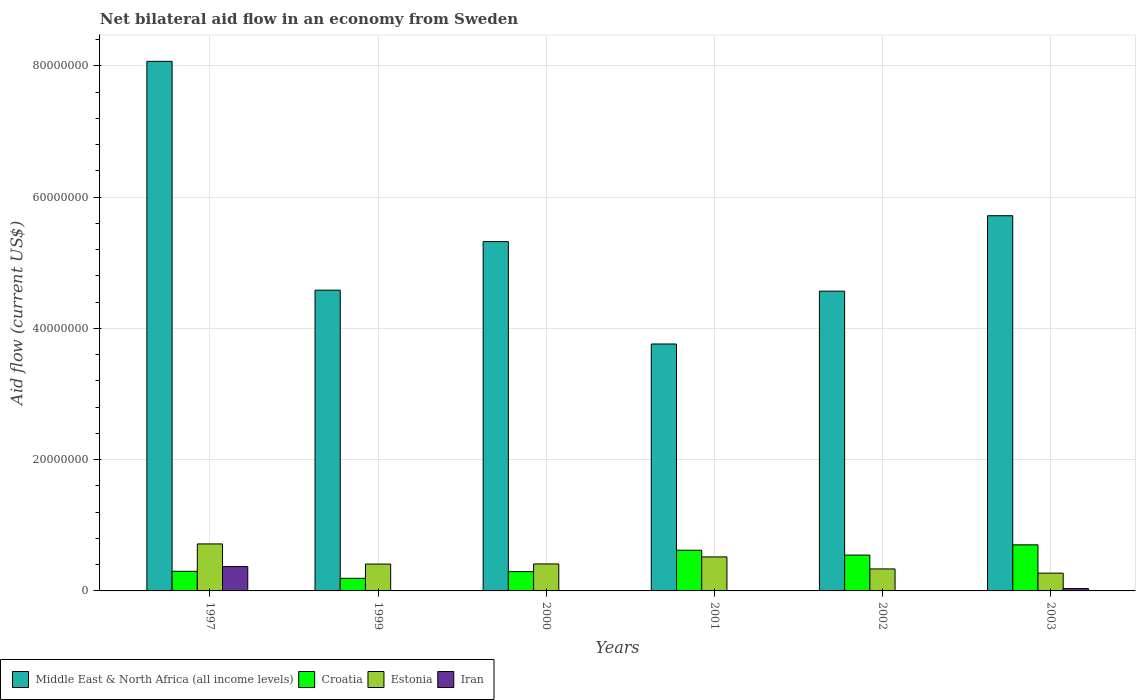How many different coloured bars are there?
Ensure brevity in your answer.  4. How many groups of bars are there?
Make the answer very short. 6. Are the number of bars per tick equal to the number of legend labels?
Keep it short and to the point. Yes. Are the number of bars on each tick of the X-axis equal?
Offer a terse response. Yes. How many bars are there on the 6th tick from the left?
Your answer should be very brief. 4. How many bars are there on the 1st tick from the right?
Ensure brevity in your answer.  4. In how many cases, is the number of bars for a given year not equal to the number of legend labels?
Make the answer very short. 0. What is the net bilateral aid flow in Estonia in 1997?
Your answer should be compact. 7.16e+06. Across all years, what is the maximum net bilateral aid flow in Croatia?
Ensure brevity in your answer.  7.02e+06. In which year was the net bilateral aid flow in Estonia maximum?
Your answer should be compact. 1997. What is the total net bilateral aid flow in Iran in the graph?
Give a very brief answer. 4.20e+06. What is the difference between the net bilateral aid flow in Middle East & North Africa (all income levels) in 1999 and that in 2003?
Ensure brevity in your answer.  -1.13e+07. What is the difference between the net bilateral aid flow in Middle East & North Africa (all income levels) in 2003 and the net bilateral aid flow in Estonia in 2002?
Offer a very short reply. 5.38e+07. What is the average net bilateral aid flow in Croatia per year?
Offer a very short reply. 4.42e+06. In the year 2001, what is the difference between the net bilateral aid flow in Croatia and net bilateral aid flow in Estonia?
Your answer should be compact. 1.02e+06. What is the ratio of the net bilateral aid flow in Iran in 1997 to that in 2003?
Your answer should be compact. 10.31. What is the difference between the highest and the second highest net bilateral aid flow in Croatia?
Make the answer very short. 8.20e+05. What is the difference between the highest and the lowest net bilateral aid flow in Croatia?
Offer a terse response. 5.10e+06. What does the 3rd bar from the left in 2001 represents?
Give a very brief answer. Estonia. What does the 3rd bar from the right in 2001 represents?
Your response must be concise. Croatia. Is it the case that in every year, the sum of the net bilateral aid flow in Croatia and net bilateral aid flow in Iran is greater than the net bilateral aid flow in Estonia?
Ensure brevity in your answer.  No. How many bars are there?
Your answer should be compact. 24. Are all the bars in the graph horizontal?
Ensure brevity in your answer.  No. Does the graph contain any zero values?
Your response must be concise. No. Where does the legend appear in the graph?
Offer a terse response. Bottom left. What is the title of the graph?
Offer a very short reply. Net bilateral aid flow in an economy from Sweden. What is the Aid flow (current US$) in Middle East & North Africa (all income levels) in 1997?
Provide a succinct answer. 8.07e+07. What is the Aid flow (current US$) in Croatia in 1997?
Your response must be concise. 2.99e+06. What is the Aid flow (current US$) of Estonia in 1997?
Provide a short and direct response. 7.16e+06. What is the Aid flow (current US$) of Iran in 1997?
Provide a succinct answer. 3.71e+06. What is the Aid flow (current US$) of Middle East & North Africa (all income levels) in 1999?
Offer a very short reply. 4.58e+07. What is the Aid flow (current US$) of Croatia in 1999?
Provide a succinct answer. 1.92e+06. What is the Aid flow (current US$) in Estonia in 1999?
Offer a very short reply. 4.09e+06. What is the Aid flow (current US$) of Middle East & North Africa (all income levels) in 2000?
Offer a terse response. 5.32e+07. What is the Aid flow (current US$) of Croatia in 2000?
Your response must be concise. 2.94e+06. What is the Aid flow (current US$) in Estonia in 2000?
Offer a very short reply. 4.11e+06. What is the Aid flow (current US$) in Iran in 2000?
Give a very brief answer. 6.00e+04. What is the Aid flow (current US$) in Middle East & North Africa (all income levels) in 2001?
Ensure brevity in your answer.  3.76e+07. What is the Aid flow (current US$) in Croatia in 2001?
Your answer should be very brief. 6.20e+06. What is the Aid flow (current US$) in Estonia in 2001?
Ensure brevity in your answer.  5.18e+06. What is the Aid flow (current US$) of Middle East & North Africa (all income levels) in 2002?
Make the answer very short. 4.57e+07. What is the Aid flow (current US$) of Croatia in 2002?
Offer a terse response. 5.46e+06. What is the Aid flow (current US$) in Estonia in 2002?
Offer a very short reply. 3.35e+06. What is the Aid flow (current US$) in Middle East & North Africa (all income levels) in 2003?
Provide a succinct answer. 5.72e+07. What is the Aid flow (current US$) of Croatia in 2003?
Make the answer very short. 7.02e+06. What is the Aid flow (current US$) of Estonia in 2003?
Your answer should be very brief. 2.71e+06. What is the Aid flow (current US$) in Iran in 2003?
Provide a succinct answer. 3.60e+05. Across all years, what is the maximum Aid flow (current US$) in Middle East & North Africa (all income levels)?
Make the answer very short. 8.07e+07. Across all years, what is the maximum Aid flow (current US$) in Croatia?
Provide a succinct answer. 7.02e+06. Across all years, what is the maximum Aid flow (current US$) of Estonia?
Your answer should be very brief. 7.16e+06. Across all years, what is the maximum Aid flow (current US$) in Iran?
Provide a short and direct response. 3.71e+06. Across all years, what is the minimum Aid flow (current US$) of Middle East & North Africa (all income levels)?
Ensure brevity in your answer.  3.76e+07. Across all years, what is the minimum Aid flow (current US$) of Croatia?
Keep it short and to the point. 1.92e+06. Across all years, what is the minimum Aid flow (current US$) in Estonia?
Provide a short and direct response. 2.71e+06. Across all years, what is the minimum Aid flow (current US$) of Iran?
Give a very brief answer. 10000. What is the total Aid flow (current US$) in Middle East & North Africa (all income levels) in the graph?
Provide a short and direct response. 3.20e+08. What is the total Aid flow (current US$) of Croatia in the graph?
Ensure brevity in your answer.  2.65e+07. What is the total Aid flow (current US$) of Estonia in the graph?
Offer a very short reply. 2.66e+07. What is the total Aid flow (current US$) of Iran in the graph?
Your answer should be very brief. 4.20e+06. What is the difference between the Aid flow (current US$) of Middle East & North Africa (all income levels) in 1997 and that in 1999?
Provide a short and direct response. 3.49e+07. What is the difference between the Aid flow (current US$) of Croatia in 1997 and that in 1999?
Your answer should be compact. 1.07e+06. What is the difference between the Aid flow (current US$) in Estonia in 1997 and that in 1999?
Your response must be concise. 3.07e+06. What is the difference between the Aid flow (current US$) in Iran in 1997 and that in 1999?
Your answer should be very brief. 3.68e+06. What is the difference between the Aid flow (current US$) in Middle East & North Africa (all income levels) in 1997 and that in 2000?
Make the answer very short. 2.75e+07. What is the difference between the Aid flow (current US$) of Croatia in 1997 and that in 2000?
Provide a succinct answer. 5.00e+04. What is the difference between the Aid flow (current US$) in Estonia in 1997 and that in 2000?
Your answer should be compact. 3.05e+06. What is the difference between the Aid flow (current US$) in Iran in 1997 and that in 2000?
Make the answer very short. 3.65e+06. What is the difference between the Aid flow (current US$) of Middle East & North Africa (all income levels) in 1997 and that in 2001?
Provide a succinct answer. 4.31e+07. What is the difference between the Aid flow (current US$) of Croatia in 1997 and that in 2001?
Your answer should be compact. -3.21e+06. What is the difference between the Aid flow (current US$) in Estonia in 1997 and that in 2001?
Offer a very short reply. 1.98e+06. What is the difference between the Aid flow (current US$) of Iran in 1997 and that in 2001?
Offer a very short reply. 3.68e+06. What is the difference between the Aid flow (current US$) of Middle East & North Africa (all income levels) in 1997 and that in 2002?
Keep it short and to the point. 3.50e+07. What is the difference between the Aid flow (current US$) in Croatia in 1997 and that in 2002?
Your answer should be very brief. -2.47e+06. What is the difference between the Aid flow (current US$) in Estonia in 1997 and that in 2002?
Offer a very short reply. 3.81e+06. What is the difference between the Aid flow (current US$) in Iran in 1997 and that in 2002?
Your answer should be very brief. 3.70e+06. What is the difference between the Aid flow (current US$) of Middle East & North Africa (all income levels) in 1997 and that in 2003?
Offer a very short reply. 2.35e+07. What is the difference between the Aid flow (current US$) of Croatia in 1997 and that in 2003?
Keep it short and to the point. -4.03e+06. What is the difference between the Aid flow (current US$) in Estonia in 1997 and that in 2003?
Give a very brief answer. 4.45e+06. What is the difference between the Aid flow (current US$) of Iran in 1997 and that in 2003?
Give a very brief answer. 3.35e+06. What is the difference between the Aid flow (current US$) in Middle East & North Africa (all income levels) in 1999 and that in 2000?
Your answer should be compact. -7.40e+06. What is the difference between the Aid flow (current US$) of Croatia in 1999 and that in 2000?
Your answer should be very brief. -1.02e+06. What is the difference between the Aid flow (current US$) of Estonia in 1999 and that in 2000?
Provide a succinct answer. -2.00e+04. What is the difference between the Aid flow (current US$) in Middle East & North Africa (all income levels) in 1999 and that in 2001?
Give a very brief answer. 8.20e+06. What is the difference between the Aid flow (current US$) in Croatia in 1999 and that in 2001?
Offer a terse response. -4.28e+06. What is the difference between the Aid flow (current US$) of Estonia in 1999 and that in 2001?
Ensure brevity in your answer.  -1.09e+06. What is the difference between the Aid flow (current US$) in Croatia in 1999 and that in 2002?
Your response must be concise. -3.54e+06. What is the difference between the Aid flow (current US$) in Estonia in 1999 and that in 2002?
Provide a succinct answer. 7.40e+05. What is the difference between the Aid flow (current US$) of Middle East & North Africa (all income levels) in 1999 and that in 2003?
Your answer should be very brief. -1.13e+07. What is the difference between the Aid flow (current US$) in Croatia in 1999 and that in 2003?
Offer a very short reply. -5.10e+06. What is the difference between the Aid flow (current US$) of Estonia in 1999 and that in 2003?
Your answer should be very brief. 1.38e+06. What is the difference between the Aid flow (current US$) in Iran in 1999 and that in 2003?
Provide a short and direct response. -3.30e+05. What is the difference between the Aid flow (current US$) of Middle East & North Africa (all income levels) in 2000 and that in 2001?
Provide a succinct answer. 1.56e+07. What is the difference between the Aid flow (current US$) of Croatia in 2000 and that in 2001?
Offer a terse response. -3.26e+06. What is the difference between the Aid flow (current US$) of Estonia in 2000 and that in 2001?
Keep it short and to the point. -1.07e+06. What is the difference between the Aid flow (current US$) of Iran in 2000 and that in 2001?
Your answer should be very brief. 3.00e+04. What is the difference between the Aid flow (current US$) of Middle East & North Africa (all income levels) in 2000 and that in 2002?
Your answer should be compact. 7.55e+06. What is the difference between the Aid flow (current US$) of Croatia in 2000 and that in 2002?
Your answer should be very brief. -2.52e+06. What is the difference between the Aid flow (current US$) of Estonia in 2000 and that in 2002?
Your answer should be very brief. 7.60e+05. What is the difference between the Aid flow (current US$) in Iran in 2000 and that in 2002?
Provide a short and direct response. 5.00e+04. What is the difference between the Aid flow (current US$) in Middle East & North Africa (all income levels) in 2000 and that in 2003?
Ensure brevity in your answer.  -3.94e+06. What is the difference between the Aid flow (current US$) of Croatia in 2000 and that in 2003?
Keep it short and to the point. -4.08e+06. What is the difference between the Aid flow (current US$) in Estonia in 2000 and that in 2003?
Your response must be concise. 1.40e+06. What is the difference between the Aid flow (current US$) in Iran in 2000 and that in 2003?
Your response must be concise. -3.00e+05. What is the difference between the Aid flow (current US$) in Middle East & North Africa (all income levels) in 2001 and that in 2002?
Your answer should be very brief. -8.05e+06. What is the difference between the Aid flow (current US$) of Croatia in 2001 and that in 2002?
Make the answer very short. 7.40e+05. What is the difference between the Aid flow (current US$) of Estonia in 2001 and that in 2002?
Your response must be concise. 1.83e+06. What is the difference between the Aid flow (current US$) in Middle East & North Africa (all income levels) in 2001 and that in 2003?
Your answer should be compact. -1.95e+07. What is the difference between the Aid flow (current US$) in Croatia in 2001 and that in 2003?
Offer a terse response. -8.20e+05. What is the difference between the Aid flow (current US$) of Estonia in 2001 and that in 2003?
Keep it short and to the point. 2.47e+06. What is the difference between the Aid flow (current US$) in Iran in 2001 and that in 2003?
Your answer should be compact. -3.30e+05. What is the difference between the Aid flow (current US$) in Middle East & North Africa (all income levels) in 2002 and that in 2003?
Offer a terse response. -1.15e+07. What is the difference between the Aid flow (current US$) of Croatia in 2002 and that in 2003?
Your answer should be compact. -1.56e+06. What is the difference between the Aid flow (current US$) in Estonia in 2002 and that in 2003?
Your answer should be compact. 6.40e+05. What is the difference between the Aid flow (current US$) of Iran in 2002 and that in 2003?
Provide a succinct answer. -3.50e+05. What is the difference between the Aid flow (current US$) in Middle East & North Africa (all income levels) in 1997 and the Aid flow (current US$) in Croatia in 1999?
Offer a very short reply. 7.88e+07. What is the difference between the Aid flow (current US$) in Middle East & North Africa (all income levels) in 1997 and the Aid flow (current US$) in Estonia in 1999?
Offer a terse response. 7.66e+07. What is the difference between the Aid flow (current US$) of Middle East & North Africa (all income levels) in 1997 and the Aid flow (current US$) of Iran in 1999?
Your answer should be compact. 8.06e+07. What is the difference between the Aid flow (current US$) of Croatia in 1997 and the Aid flow (current US$) of Estonia in 1999?
Offer a very short reply. -1.10e+06. What is the difference between the Aid flow (current US$) of Croatia in 1997 and the Aid flow (current US$) of Iran in 1999?
Make the answer very short. 2.96e+06. What is the difference between the Aid flow (current US$) of Estonia in 1997 and the Aid flow (current US$) of Iran in 1999?
Make the answer very short. 7.13e+06. What is the difference between the Aid flow (current US$) of Middle East & North Africa (all income levels) in 1997 and the Aid flow (current US$) of Croatia in 2000?
Provide a succinct answer. 7.77e+07. What is the difference between the Aid flow (current US$) of Middle East & North Africa (all income levels) in 1997 and the Aid flow (current US$) of Estonia in 2000?
Provide a short and direct response. 7.66e+07. What is the difference between the Aid flow (current US$) in Middle East & North Africa (all income levels) in 1997 and the Aid flow (current US$) in Iran in 2000?
Ensure brevity in your answer.  8.06e+07. What is the difference between the Aid flow (current US$) in Croatia in 1997 and the Aid flow (current US$) in Estonia in 2000?
Give a very brief answer. -1.12e+06. What is the difference between the Aid flow (current US$) in Croatia in 1997 and the Aid flow (current US$) in Iran in 2000?
Ensure brevity in your answer.  2.93e+06. What is the difference between the Aid flow (current US$) of Estonia in 1997 and the Aid flow (current US$) of Iran in 2000?
Ensure brevity in your answer.  7.10e+06. What is the difference between the Aid flow (current US$) of Middle East & North Africa (all income levels) in 1997 and the Aid flow (current US$) of Croatia in 2001?
Provide a succinct answer. 7.45e+07. What is the difference between the Aid flow (current US$) of Middle East & North Africa (all income levels) in 1997 and the Aid flow (current US$) of Estonia in 2001?
Provide a short and direct response. 7.55e+07. What is the difference between the Aid flow (current US$) in Middle East & North Africa (all income levels) in 1997 and the Aid flow (current US$) in Iran in 2001?
Offer a very short reply. 8.06e+07. What is the difference between the Aid flow (current US$) of Croatia in 1997 and the Aid flow (current US$) of Estonia in 2001?
Your answer should be compact. -2.19e+06. What is the difference between the Aid flow (current US$) in Croatia in 1997 and the Aid flow (current US$) in Iran in 2001?
Your answer should be very brief. 2.96e+06. What is the difference between the Aid flow (current US$) of Estonia in 1997 and the Aid flow (current US$) of Iran in 2001?
Ensure brevity in your answer.  7.13e+06. What is the difference between the Aid flow (current US$) in Middle East & North Africa (all income levels) in 1997 and the Aid flow (current US$) in Croatia in 2002?
Give a very brief answer. 7.52e+07. What is the difference between the Aid flow (current US$) of Middle East & North Africa (all income levels) in 1997 and the Aid flow (current US$) of Estonia in 2002?
Your response must be concise. 7.73e+07. What is the difference between the Aid flow (current US$) in Middle East & North Africa (all income levels) in 1997 and the Aid flow (current US$) in Iran in 2002?
Offer a very short reply. 8.07e+07. What is the difference between the Aid flow (current US$) in Croatia in 1997 and the Aid flow (current US$) in Estonia in 2002?
Give a very brief answer. -3.60e+05. What is the difference between the Aid flow (current US$) in Croatia in 1997 and the Aid flow (current US$) in Iran in 2002?
Your answer should be compact. 2.98e+06. What is the difference between the Aid flow (current US$) in Estonia in 1997 and the Aid flow (current US$) in Iran in 2002?
Your answer should be very brief. 7.15e+06. What is the difference between the Aid flow (current US$) of Middle East & North Africa (all income levels) in 1997 and the Aid flow (current US$) of Croatia in 2003?
Make the answer very short. 7.37e+07. What is the difference between the Aid flow (current US$) of Middle East & North Africa (all income levels) in 1997 and the Aid flow (current US$) of Estonia in 2003?
Your response must be concise. 7.80e+07. What is the difference between the Aid flow (current US$) of Middle East & North Africa (all income levels) in 1997 and the Aid flow (current US$) of Iran in 2003?
Give a very brief answer. 8.03e+07. What is the difference between the Aid flow (current US$) in Croatia in 1997 and the Aid flow (current US$) in Iran in 2003?
Ensure brevity in your answer.  2.63e+06. What is the difference between the Aid flow (current US$) of Estonia in 1997 and the Aid flow (current US$) of Iran in 2003?
Your response must be concise. 6.80e+06. What is the difference between the Aid flow (current US$) of Middle East & North Africa (all income levels) in 1999 and the Aid flow (current US$) of Croatia in 2000?
Your answer should be compact. 4.29e+07. What is the difference between the Aid flow (current US$) in Middle East & North Africa (all income levels) in 1999 and the Aid flow (current US$) in Estonia in 2000?
Offer a very short reply. 4.17e+07. What is the difference between the Aid flow (current US$) in Middle East & North Africa (all income levels) in 1999 and the Aid flow (current US$) in Iran in 2000?
Your answer should be compact. 4.58e+07. What is the difference between the Aid flow (current US$) of Croatia in 1999 and the Aid flow (current US$) of Estonia in 2000?
Offer a terse response. -2.19e+06. What is the difference between the Aid flow (current US$) of Croatia in 1999 and the Aid flow (current US$) of Iran in 2000?
Provide a short and direct response. 1.86e+06. What is the difference between the Aid flow (current US$) in Estonia in 1999 and the Aid flow (current US$) in Iran in 2000?
Offer a very short reply. 4.03e+06. What is the difference between the Aid flow (current US$) of Middle East & North Africa (all income levels) in 1999 and the Aid flow (current US$) of Croatia in 2001?
Your answer should be very brief. 3.96e+07. What is the difference between the Aid flow (current US$) of Middle East & North Africa (all income levels) in 1999 and the Aid flow (current US$) of Estonia in 2001?
Provide a succinct answer. 4.06e+07. What is the difference between the Aid flow (current US$) in Middle East & North Africa (all income levels) in 1999 and the Aid flow (current US$) in Iran in 2001?
Ensure brevity in your answer.  4.58e+07. What is the difference between the Aid flow (current US$) in Croatia in 1999 and the Aid flow (current US$) in Estonia in 2001?
Give a very brief answer. -3.26e+06. What is the difference between the Aid flow (current US$) of Croatia in 1999 and the Aid flow (current US$) of Iran in 2001?
Your answer should be very brief. 1.89e+06. What is the difference between the Aid flow (current US$) in Estonia in 1999 and the Aid flow (current US$) in Iran in 2001?
Your response must be concise. 4.06e+06. What is the difference between the Aid flow (current US$) of Middle East & North Africa (all income levels) in 1999 and the Aid flow (current US$) of Croatia in 2002?
Offer a terse response. 4.04e+07. What is the difference between the Aid flow (current US$) in Middle East & North Africa (all income levels) in 1999 and the Aid flow (current US$) in Estonia in 2002?
Make the answer very short. 4.25e+07. What is the difference between the Aid flow (current US$) in Middle East & North Africa (all income levels) in 1999 and the Aid flow (current US$) in Iran in 2002?
Offer a very short reply. 4.58e+07. What is the difference between the Aid flow (current US$) in Croatia in 1999 and the Aid flow (current US$) in Estonia in 2002?
Keep it short and to the point. -1.43e+06. What is the difference between the Aid flow (current US$) of Croatia in 1999 and the Aid flow (current US$) of Iran in 2002?
Provide a short and direct response. 1.91e+06. What is the difference between the Aid flow (current US$) of Estonia in 1999 and the Aid flow (current US$) of Iran in 2002?
Provide a succinct answer. 4.08e+06. What is the difference between the Aid flow (current US$) of Middle East & North Africa (all income levels) in 1999 and the Aid flow (current US$) of Croatia in 2003?
Your answer should be compact. 3.88e+07. What is the difference between the Aid flow (current US$) in Middle East & North Africa (all income levels) in 1999 and the Aid flow (current US$) in Estonia in 2003?
Your answer should be compact. 4.31e+07. What is the difference between the Aid flow (current US$) in Middle East & North Africa (all income levels) in 1999 and the Aid flow (current US$) in Iran in 2003?
Provide a succinct answer. 4.55e+07. What is the difference between the Aid flow (current US$) of Croatia in 1999 and the Aid flow (current US$) of Estonia in 2003?
Ensure brevity in your answer.  -7.90e+05. What is the difference between the Aid flow (current US$) of Croatia in 1999 and the Aid flow (current US$) of Iran in 2003?
Offer a very short reply. 1.56e+06. What is the difference between the Aid flow (current US$) in Estonia in 1999 and the Aid flow (current US$) in Iran in 2003?
Offer a very short reply. 3.73e+06. What is the difference between the Aid flow (current US$) of Middle East & North Africa (all income levels) in 2000 and the Aid flow (current US$) of Croatia in 2001?
Keep it short and to the point. 4.70e+07. What is the difference between the Aid flow (current US$) in Middle East & North Africa (all income levels) in 2000 and the Aid flow (current US$) in Estonia in 2001?
Keep it short and to the point. 4.80e+07. What is the difference between the Aid flow (current US$) of Middle East & North Africa (all income levels) in 2000 and the Aid flow (current US$) of Iran in 2001?
Your answer should be very brief. 5.32e+07. What is the difference between the Aid flow (current US$) in Croatia in 2000 and the Aid flow (current US$) in Estonia in 2001?
Keep it short and to the point. -2.24e+06. What is the difference between the Aid flow (current US$) of Croatia in 2000 and the Aid flow (current US$) of Iran in 2001?
Provide a short and direct response. 2.91e+06. What is the difference between the Aid flow (current US$) of Estonia in 2000 and the Aid flow (current US$) of Iran in 2001?
Your response must be concise. 4.08e+06. What is the difference between the Aid flow (current US$) of Middle East & North Africa (all income levels) in 2000 and the Aid flow (current US$) of Croatia in 2002?
Provide a succinct answer. 4.78e+07. What is the difference between the Aid flow (current US$) of Middle East & North Africa (all income levels) in 2000 and the Aid flow (current US$) of Estonia in 2002?
Keep it short and to the point. 4.99e+07. What is the difference between the Aid flow (current US$) in Middle East & North Africa (all income levels) in 2000 and the Aid flow (current US$) in Iran in 2002?
Keep it short and to the point. 5.32e+07. What is the difference between the Aid flow (current US$) of Croatia in 2000 and the Aid flow (current US$) of Estonia in 2002?
Provide a short and direct response. -4.10e+05. What is the difference between the Aid flow (current US$) of Croatia in 2000 and the Aid flow (current US$) of Iran in 2002?
Provide a short and direct response. 2.93e+06. What is the difference between the Aid flow (current US$) in Estonia in 2000 and the Aid flow (current US$) in Iran in 2002?
Provide a succinct answer. 4.10e+06. What is the difference between the Aid flow (current US$) in Middle East & North Africa (all income levels) in 2000 and the Aid flow (current US$) in Croatia in 2003?
Your answer should be compact. 4.62e+07. What is the difference between the Aid flow (current US$) of Middle East & North Africa (all income levels) in 2000 and the Aid flow (current US$) of Estonia in 2003?
Provide a succinct answer. 5.05e+07. What is the difference between the Aid flow (current US$) in Middle East & North Africa (all income levels) in 2000 and the Aid flow (current US$) in Iran in 2003?
Your answer should be compact. 5.29e+07. What is the difference between the Aid flow (current US$) in Croatia in 2000 and the Aid flow (current US$) in Estonia in 2003?
Your answer should be compact. 2.30e+05. What is the difference between the Aid flow (current US$) of Croatia in 2000 and the Aid flow (current US$) of Iran in 2003?
Keep it short and to the point. 2.58e+06. What is the difference between the Aid flow (current US$) of Estonia in 2000 and the Aid flow (current US$) of Iran in 2003?
Your answer should be compact. 3.75e+06. What is the difference between the Aid flow (current US$) of Middle East & North Africa (all income levels) in 2001 and the Aid flow (current US$) of Croatia in 2002?
Your answer should be very brief. 3.22e+07. What is the difference between the Aid flow (current US$) in Middle East & North Africa (all income levels) in 2001 and the Aid flow (current US$) in Estonia in 2002?
Your answer should be very brief. 3.43e+07. What is the difference between the Aid flow (current US$) in Middle East & North Africa (all income levels) in 2001 and the Aid flow (current US$) in Iran in 2002?
Offer a very short reply. 3.76e+07. What is the difference between the Aid flow (current US$) of Croatia in 2001 and the Aid flow (current US$) of Estonia in 2002?
Give a very brief answer. 2.85e+06. What is the difference between the Aid flow (current US$) in Croatia in 2001 and the Aid flow (current US$) in Iran in 2002?
Your response must be concise. 6.19e+06. What is the difference between the Aid flow (current US$) of Estonia in 2001 and the Aid flow (current US$) of Iran in 2002?
Offer a very short reply. 5.17e+06. What is the difference between the Aid flow (current US$) in Middle East & North Africa (all income levels) in 2001 and the Aid flow (current US$) in Croatia in 2003?
Your answer should be very brief. 3.06e+07. What is the difference between the Aid flow (current US$) in Middle East & North Africa (all income levels) in 2001 and the Aid flow (current US$) in Estonia in 2003?
Your response must be concise. 3.49e+07. What is the difference between the Aid flow (current US$) in Middle East & North Africa (all income levels) in 2001 and the Aid flow (current US$) in Iran in 2003?
Your answer should be compact. 3.73e+07. What is the difference between the Aid flow (current US$) in Croatia in 2001 and the Aid flow (current US$) in Estonia in 2003?
Give a very brief answer. 3.49e+06. What is the difference between the Aid flow (current US$) of Croatia in 2001 and the Aid flow (current US$) of Iran in 2003?
Offer a very short reply. 5.84e+06. What is the difference between the Aid flow (current US$) of Estonia in 2001 and the Aid flow (current US$) of Iran in 2003?
Offer a very short reply. 4.82e+06. What is the difference between the Aid flow (current US$) of Middle East & North Africa (all income levels) in 2002 and the Aid flow (current US$) of Croatia in 2003?
Your response must be concise. 3.86e+07. What is the difference between the Aid flow (current US$) in Middle East & North Africa (all income levels) in 2002 and the Aid flow (current US$) in Estonia in 2003?
Offer a terse response. 4.30e+07. What is the difference between the Aid flow (current US$) in Middle East & North Africa (all income levels) in 2002 and the Aid flow (current US$) in Iran in 2003?
Provide a short and direct response. 4.53e+07. What is the difference between the Aid flow (current US$) of Croatia in 2002 and the Aid flow (current US$) of Estonia in 2003?
Offer a very short reply. 2.75e+06. What is the difference between the Aid flow (current US$) of Croatia in 2002 and the Aid flow (current US$) of Iran in 2003?
Your answer should be compact. 5.10e+06. What is the difference between the Aid flow (current US$) of Estonia in 2002 and the Aid flow (current US$) of Iran in 2003?
Offer a terse response. 2.99e+06. What is the average Aid flow (current US$) in Middle East & North Africa (all income levels) per year?
Keep it short and to the point. 5.34e+07. What is the average Aid flow (current US$) of Croatia per year?
Ensure brevity in your answer.  4.42e+06. What is the average Aid flow (current US$) of Estonia per year?
Provide a short and direct response. 4.43e+06. In the year 1997, what is the difference between the Aid flow (current US$) of Middle East & North Africa (all income levels) and Aid flow (current US$) of Croatia?
Your answer should be compact. 7.77e+07. In the year 1997, what is the difference between the Aid flow (current US$) of Middle East & North Africa (all income levels) and Aid flow (current US$) of Estonia?
Your answer should be very brief. 7.35e+07. In the year 1997, what is the difference between the Aid flow (current US$) of Middle East & North Africa (all income levels) and Aid flow (current US$) of Iran?
Your answer should be very brief. 7.70e+07. In the year 1997, what is the difference between the Aid flow (current US$) of Croatia and Aid flow (current US$) of Estonia?
Give a very brief answer. -4.17e+06. In the year 1997, what is the difference between the Aid flow (current US$) in Croatia and Aid flow (current US$) in Iran?
Make the answer very short. -7.20e+05. In the year 1997, what is the difference between the Aid flow (current US$) of Estonia and Aid flow (current US$) of Iran?
Your answer should be compact. 3.45e+06. In the year 1999, what is the difference between the Aid flow (current US$) of Middle East & North Africa (all income levels) and Aid flow (current US$) of Croatia?
Keep it short and to the point. 4.39e+07. In the year 1999, what is the difference between the Aid flow (current US$) of Middle East & North Africa (all income levels) and Aid flow (current US$) of Estonia?
Offer a terse response. 4.17e+07. In the year 1999, what is the difference between the Aid flow (current US$) of Middle East & North Africa (all income levels) and Aid flow (current US$) of Iran?
Keep it short and to the point. 4.58e+07. In the year 1999, what is the difference between the Aid flow (current US$) in Croatia and Aid flow (current US$) in Estonia?
Provide a short and direct response. -2.17e+06. In the year 1999, what is the difference between the Aid flow (current US$) of Croatia and Aid flow (current US$) of Iran?
Provide a short and direct response. 1.89e+06. In the year 1999, what is the difference between the Aid flow (current US$) of Estonia and Aid flow (current US$) of Iran?
Keep it short and to the point. 4.06e+06. In the year 2000, what is the difference between the Aid flow (current US$) of Middle East & North Africa (all income levels) and Aid flow (current US$) of Croatia?
Your answer should be very brief. 5.03e+07. In the year 2000, what is the difference between the Aid flow (current US$) of Middle East & North Africa (all income levels) and Aid flow (current US$) of Estonia?
Make the answer very short. 4.91e+07. In the year 2000, what is the difference between the Aid flow (current US$) of Middle East & North Africa (all income levels) and Aid flow (current US$) of Iran?
Ensure brevity in your answer.  5.32e+07. In the year 2000, what is the difference between the Aid flow (current US$) of Croatia and Aid flow (current US$) of Estonia?
Make the answer very short. -1.17e+06. In the year 2000, what is the difference between the Aid flow (current US$) of Croatia and Aid flow (current US$) of Iran?
Make the answer very short. 2.88e+06. In the year 2000, what is the difference between the Aid flow (current US$) in Estonia and Aid flow (current US$) in Iran?
Ensure brevity in your answer.  4.05e+06. In the year 2001, what is the difference between the Aid flow (current US$) in Middle East & North Africa (all income levels) and Aid flow (current US$) in Croatia?
Provide a succinct answer. 3.14e+07. In the year 2001, what is the difference between the Aid flow (current US$) in Middle East & North Africa (all income levels) and Aid flow (current US$) in Estonia?
Offer a very short reply. 3.24e+07. In the year 2001, what is the difference between the Aid flow (current US$) in Middle East & North Africa (all income levels) and Aid flow (current US$) in Iran?
Make the answer very short. 3.76e+07. In the year 2001, what is the difference between the Aid flow (current US$) of Croatia and Aid flow (current US$) of Estonia?
Ensure brevity in your answer.  1.02e+06. In the year 2001, what is the difference between the Aid flow (current US$) in Croatia and Aid flow (current US$) in Iran?
Offer a very short reply. 6.17e+06. In the year 2001, what is the difference between the Aid flow (current US$) of Estonia and Aid flow (current US$) of Iran?
Your answer should be compact. 5.15e+06. In the year 2002, what is the difference between the Aid flow (current US$) of Middle East & North Africa (all income levels) and Aid flow (current US$) of Croatia?
Ensure brevity in your answer.  4.02e+07. In the year 2002, what is the difference between the Aid flow (current US$) of Middle East & North Africa (all income levels) and Aid flow (current US$) of Estonia?
Offer a terse response. 4.23e+07. In the year 2002, what is the difference between the Aid flow (current US$) in Middle East & North Africa (all income levels) and Aid flow (current US$) in Iran?
Make the answer very short. 4.57e+07. In the year 2002, what is the difference between the Aid flow (current US$) of Croatia and Aid flow (current US$) of Estonia?
Give a very brief answer. 2.11e+06. In the year 2002, what is the difference between the Aid flow (current US$) in Croatia and Aid flow (current US$) in Iran?
Make the answer very short. 5.45e+06. In the year 2002, what is the difference between the Aid flow (current US$) in Estonia and Aid flow (current US$) in Iran?
Your answer should be compact. 3.34e+06. In the year 2003, what is the difference between the Aid flow (current US$) of Middle East & North Africa (all income levels) and Aid flow (current US$) of Croatia?
Your answer should be compact. 5.01e+07. In the year 2003, what is the difference between the Aid flow (current US$) in Middle East & North Africa (all income levels) and Aid flow (current US$) in Estonia?
Provide a short and direct response. 5.44e+07. In the year 2003, what is the difference between the Aid flow (current US$) in Middle East & North Africa (all income levels) and Aid flow (current US$) in Iran?
Your response must be concise. 5.68e+07. In the year 2003, what is the difference between the Aid flow (current US$) in Croatia and Aid flow (current US$) in Estonia?
Provide a short and direct response. 4.31e+06. In the year 2003, what is the difference between the Aid flow (current US$) of Croatia and Aid flow (current US$) of Iran?
Offer a very short reply. 6.66e+06. In the year 2003, what is the difference between the Aid flow (current US$) in Estonia and Aid flow (current US$) in Iran?
Offer a terse response. 2.35e+06. What is the ratio of the Aid flow (current US$) in Middle East & North Africa (all income levels) in 1997 to that in 1999?
Your answer should be compact. 1.76. What is the ratio of the Aid flow (current US$) of Croatia in 1997 to that in 1999?
Offer a very short reply. 1.56. What is the ratio of the Aid flow (current US$) in Estonia in 1997 to that in 1999?
Ensure brevity in your answer.  1.75. What is the ratio of the Aid flow (current US$) in Iran in 1997 to that in 1999?
Offer a very short reply. 123.67. What is the ratio of the Aid flow (current US$) in Middle East & North Africa (all income levels) in 1997 to that in 2000?
Offer a terse response. 1.52. What is the ratio of the Aid flow (current US$) of Croatia in 1997 to that in 2000?
Offer a terse response. 1.02. What is the ratio of the Aid flow (current US$) in Estonia in 1997 to that in 2000?
Give a very brief answer. 1.74. What is the ratio of the Aid flow (current US$) of Iran in 1997 to that in 2000?
Offer a terse response. 61.83. What is the ratio of the Aid flow (current US$) in Middle East & North Africa (all income levels) in 1997 to that in 2001?
Your answer should be very brief. 2.14. What is the ratio of the Aid flow (current US$) of Croatia in 1997 to that in 2001?
Your answer should be compact. 0.48. What is the ratio of the Aid flow (current US$) of Estonia in 1997 to that in 2001?
Provide a short and direct response. 1.38. What is the ratio of the Aid flow (current US$) of Iran in 1997 to that in 2001?
Keep it short and to the point. 123.67. What is the ratio of the Aid flow (current US$) in Middle East & North Africa (all income levels) in 1997 to that in 2002?
Ensure brevity in your answer.  1.77. What is the ratio of the Aid flow (current US$) in Croatia in 1997 to that in 2002?
Your answer should be compact. 0.55. What is the ratio of the Aid flow (current US$) in Estonia in 1997 to that in 2002?
Ensure brevity in your answer.  2.14. What is the ratio of the Aid flow (current US$) in Iran in 1997 to that in 2002?
Offer a very short reply. 371. What is the ratio of the Aid flow (current US$) in Middle East & North Africa (all income levels) in 1997 to that in 2003?
Provide a short and direct response. 1.41. What is the ratio of the Aid flow (current US$) of Croatia in 1997 to that in 2003?
Offer a very short reply. 0.43. What is the ratio of the Aid flow (current US$) in Estonia in 1997 to that in 2003?
Make the answer very short. 2.64. What is the ratio of the Aid flow (current US$) in Iran in 1997 to that in 2003?
Ensure brevity in your answer.  10.31. What is the ratio of the Aid flow (current US$) of Middle East & North Africa (all income levels) in 1999 to that in 2000?
Provide a short and direct response. 0.86. What is the ratio of the Aid flow (current US$) of Croatia in 1999 to that in 2000?
Make the answer very short. 0.65. What is the ratio of the Aid flow (current US$) in Estonia in 1999 to that in 2000?
Offer a very short reply. 1. What is the ratio of the Aid flow (current US$) of Middle East & North Africa (all income levels) in 1999 to that in 2001?
Your answer should be very brief. 1.22. What is the ratio of the Aid flow (current US$) of Croatia in 1999 to that in 2001?
Make the answer very short. 0.31. What is the ratio of the Aid flow (current US$) in Estonia in 1999 to that in 2001?
Offer a very short reply. 0.79. What is the ratio of the Aid flow (current US$) of Croatia in 1999 to that in 2002?
Provide a short and direct response. 0.35. What is the ratio of the Aid flow (current US$) of Estonia in 1999 to that in 2002?
Keep it short and to the point. 1.22. What is the ratio of the Aid flow (current US$) of Middle East & North Africa (all income levels) in 1999 to that in 2003?
Ensure brevity in your answer.  0.8. What is the ratio of the Aid flow (current US$) of Croatia in 1999 to that in 2003?
Offer a very short reply. 0.27. What is the ratio of the Aid flow (current US$) of Estonia in 1999 to that in 2003?
Ensure brevity in your answer.  1.51. What is the ratio of the Aid flow (current US$) in Iran in 1999 to that in 2003?
Keep it short and to the point. 0.08. What is the ratio of the Aid flow (current US$) of Middle East & North Africa (all income levels) in 2000 to that in 2001?
Ensure brevity in your answer.  1.41. What is the ratio of the Aid flow (current US$) in Croatia in 2000 to that in 2001?
Give a very brief answer. 0.47. What is the ratio of the Aid flow (current US$) in Estonia in 2000 to that in 2001?
Your answer should be very brief. 0.79. What is the ratio of the Aid flow (current US$) of Middle East & North Africa (all income levels) in 2000 to that in 2002?
Make the answer very short. 1.17. What is the ratio of the Aid flow (current US$) in Croatia in 2000 to that in 2002?
Ensure brevity in your answer.  0.54. What is the ratio of the Aid flow (current US$) in Estonia in 2000 to that in 2002?
Provide a succinct answer. 1.23. What is the ratio of the Aid flow (current US$) in Middle East & North Africa (all income levels) in 2000 to that in 2003?
Your response must be concise. 0.93. What is the ratio of the Aid flow (current US$) in Croatia in 2000 to that in 2003?
Provide a short and direct response. 0.42. What is the ratio of the Aid flow (current US$) in Estonia in 2000 to that in 2003?
Give a very brief answer. 1.52. What is the ratio of the Aid flow (current US$) of Middle East & North Africa (all income levels) in 2001 to that in 2002?
Your answer should be compact. 0.82. What is the ratio of the Aid flow (current US$) of Croatia in 2001 to that in 2002?
Offer a terse response. 1.14. What is the ratio of the Aid flow (current US$) of Estonia in 2001 to that in 2002?
Your response must be concise. 1.55. What is the ratio of the Aid flow (current US$) in Iran in 2001 to that in 2002?
Your response must be concise. 3. What is the ratio of the Aid flow (current US$) in Middle East & North Africa (all income levels) in 2001 to that in 2003?
Your response must be concise. 0.66. What is the ratio of the Aid flow (current US$) of Croatia in 2001 to that in 2003?
Give a very brief answer. 0.88. What is the ratio of the Aid flow (current US$) of Estonia in 2001 to that in 2003?
Keep it short and to the point. 1.91. What is the ratio of the Aid flow (current US$) in Iran in 2001 to that in 2003?
Your answer should be very brief. 0.08. What is the ratio of the Aid flow (current US$) in Middle East & North Africa (all income levels) in 2002 to that in 2003?
Make the answer very short. 0.8. What is the ratio of the Aid flow (current US$) in Estonia in 2002 to that in 2003?
Keep it short and to the point. 1.24. What is the ratio of the Aid flow (current US$) of Iran in 2002 to that in 2003?
Provide a short and direct response. 0.03. What is the difference between the highest and the second highest Aid flow (current US$) of Middle East & North Africa (all income levels)?
Ensure brevity in your answer.  2.35e+07. What is the difference between the highest and the second highest Aid flow (current US$) of Croatia?
Ensure brevity in your answer.  8.20e+05. What is the difference between the highest and the second highest Aid flow (current US$) in Estonia?
Offer a terse response. 1.98e+06. What is the difference between the highest and the second highest Aid flow (current US$) of Iran?
Your answer should be compact. 3.35e+06. What is the difference between the highest and the lowest Aid flow (current US$) in Middle East & North Africa (all income levels)?
Make the answer very short. 4.31e+07. What is the difference between the highest and the lowest Aid flow (current US$) of Croatia?
Provide a short and direct response. 5.10e+06. What is the difference between the highest and the lowest Aid flow (current US$) in Estonia?
Make the answer very short. 4.45e+06. What is the difference between the highest and the lowest Aid flow (current US$) in Iran?
Your response must be concise. 3.70e+06. 